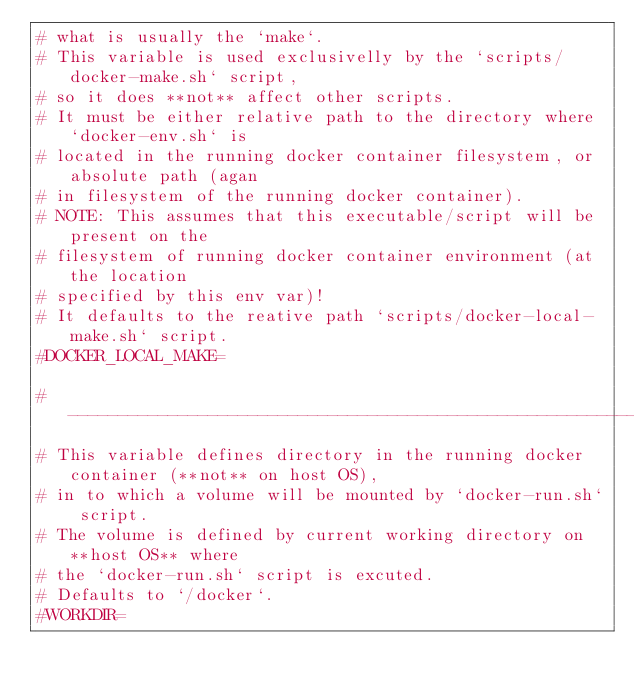Convert code to text. <code><loc_0><loc_0><loc_500><loc_500><_Bash_># what is usually the `make`.
# This variable is used exclusivelly by the `scripts/docker-make.sh` script,
# so it does **not** affect other scripts.
# It must be either relative path to the directory where `docker-env.sh` is
# located in the running docker container filesystem, or absolute path (agan
# in filesystem of the running docker container).
# NOTE: This assumes that this executable/script will be present on the
# filesystem of running docker container environment (at the location 
# specified by this env var)!
# It defaults to the reative path `scripts/docker-local-make.sh` script.
#DOCKER_LOCAL_MAKE=

# ---------------------------------------------------------------------------
# This variable defines directory in the running docker container (**not** on host OS),
# in to which a volume will be mounted by `docker-run.sh` script.
# The volume is defined by current working directory on **host OS** where
# the `docker-run.sh` script is excuted.
# Defaults to `/docker`.
#WORKDIR=

</code> 